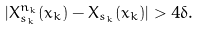<formula> <loc_0><loc_0><loc_500><loc_500>| X ^ { n _ { k } } _ { s _ { k } } ( x _ { k } ) - X _ { s _ { k } } ( x _ { k } ) | > 4 \delta .</formula> 